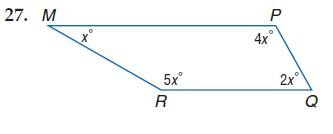Answer the mathemtical geometry problem and directly provide the correct option letter.
Question: Find m \angle P.
Choices: A: 30 B: 60 C: 120 D: 150 C 